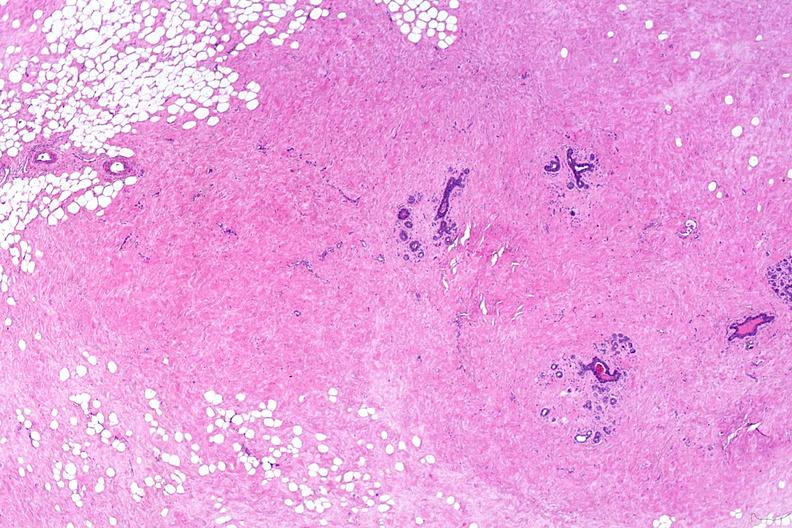what is present?
Answer the question using a single word or phrase. Female reproductive 